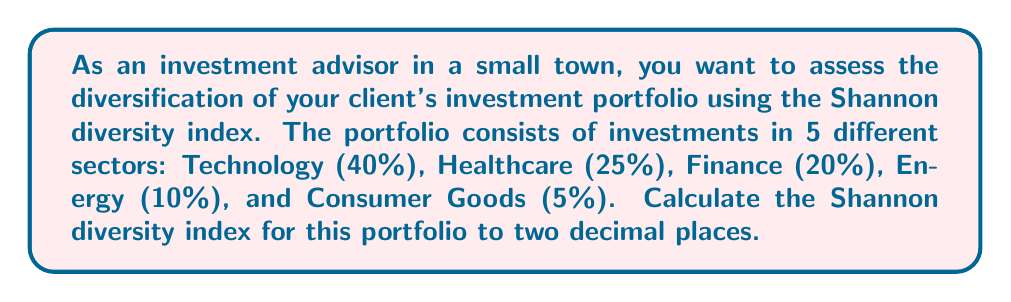Could you help me with this problem? The Shannon diversity index is commonly used in ecology to measure species diversity, but it can also be applied to investment portfolios to assess diversification. The formula for the Shannon diversity index is:

$$H' = -\sum_{i=1}^{R} p_i \ln(p_i)$$

Where:
$H'$ is the Shannon diversity index
$R$ is the number of categories (in this case, investment sectors)
$p_i$ is the proportion of investments in the $i$-th sector

To calculate the Shannon diversity index for this portfolio:

1. Identify the proportions:
   $p_1 = 0.40$ (Technology)
   $p_2 = 0.25$ (Healthcare)
   $p_3 = 0.20$ (Finance)
   $p_4 = 0.10$ (Energy)
   $p_5 = 0.05$ (Consumer Goods)

2. Calculate $p_i \ln(p_i)$ for each sector:
   Technology: $0.40 \ln(0.40) = -0.3665$
   Healthcare: $0.25 \ln(0.25) = -0.3466$
   Finance: $0.20 \ln(0.20) = -0.3219$
   Energy: $0.10 \ln(0.10) = -0.2303$
   Consumer Goods: $0.05 \ln(0.05) = -0.1498$

3. Sum the negative values:
   $H' = -(-0.3665 - 0.3466 - 0.3219 - 0.2303 - 0.1498)$

4. Calculate the final result:
   $H' = 1.4151$

5. Round to two decimal places:
   $H' = 1.42$

The Shannon diversity index for this portfolio is 1.42, indicating a moderate level of diversification. A higher value would indicate greater diversification, while a lower value would suggest less diversification.
Answer: 1.42 